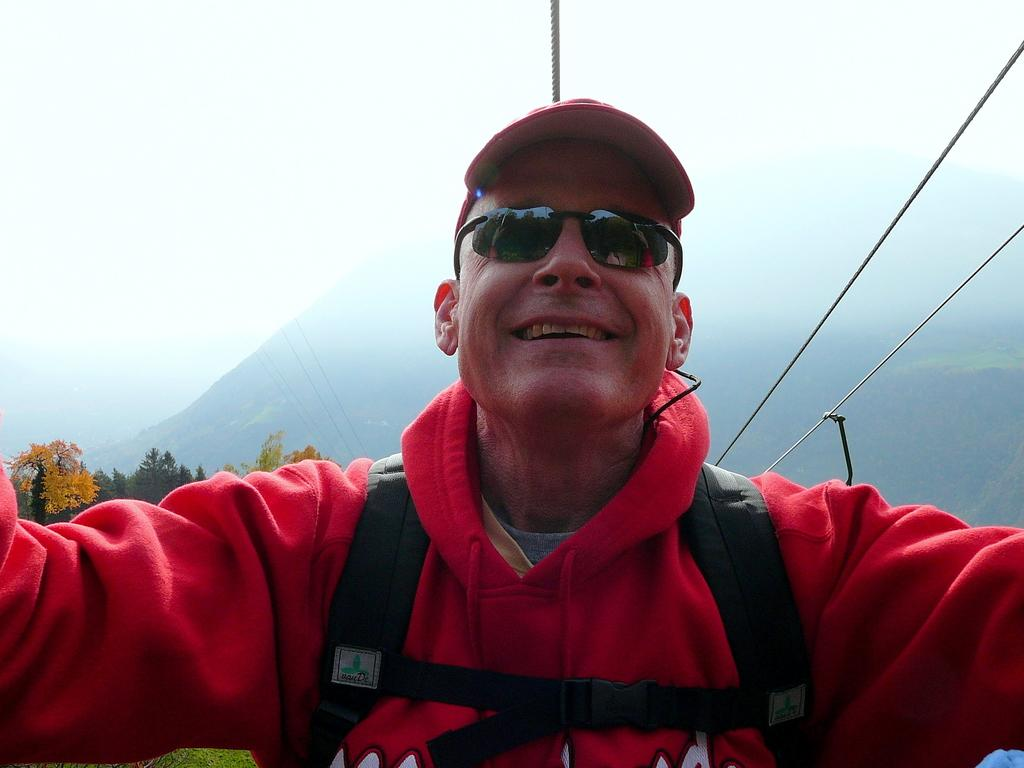Who or what is present in the image? There is a person in the image. What type of natural environment is visible in the image? Trees and mountains are visible in the image. What objects can be seen in the image that might be used for climbing or support? Ropes are visible in the image. What is visible at the top of the image? The sky is visible at the top of the image. Can you describe the sense of smell in the image? There is no information about the sense of smell in the image, as it only contains visual elements. 